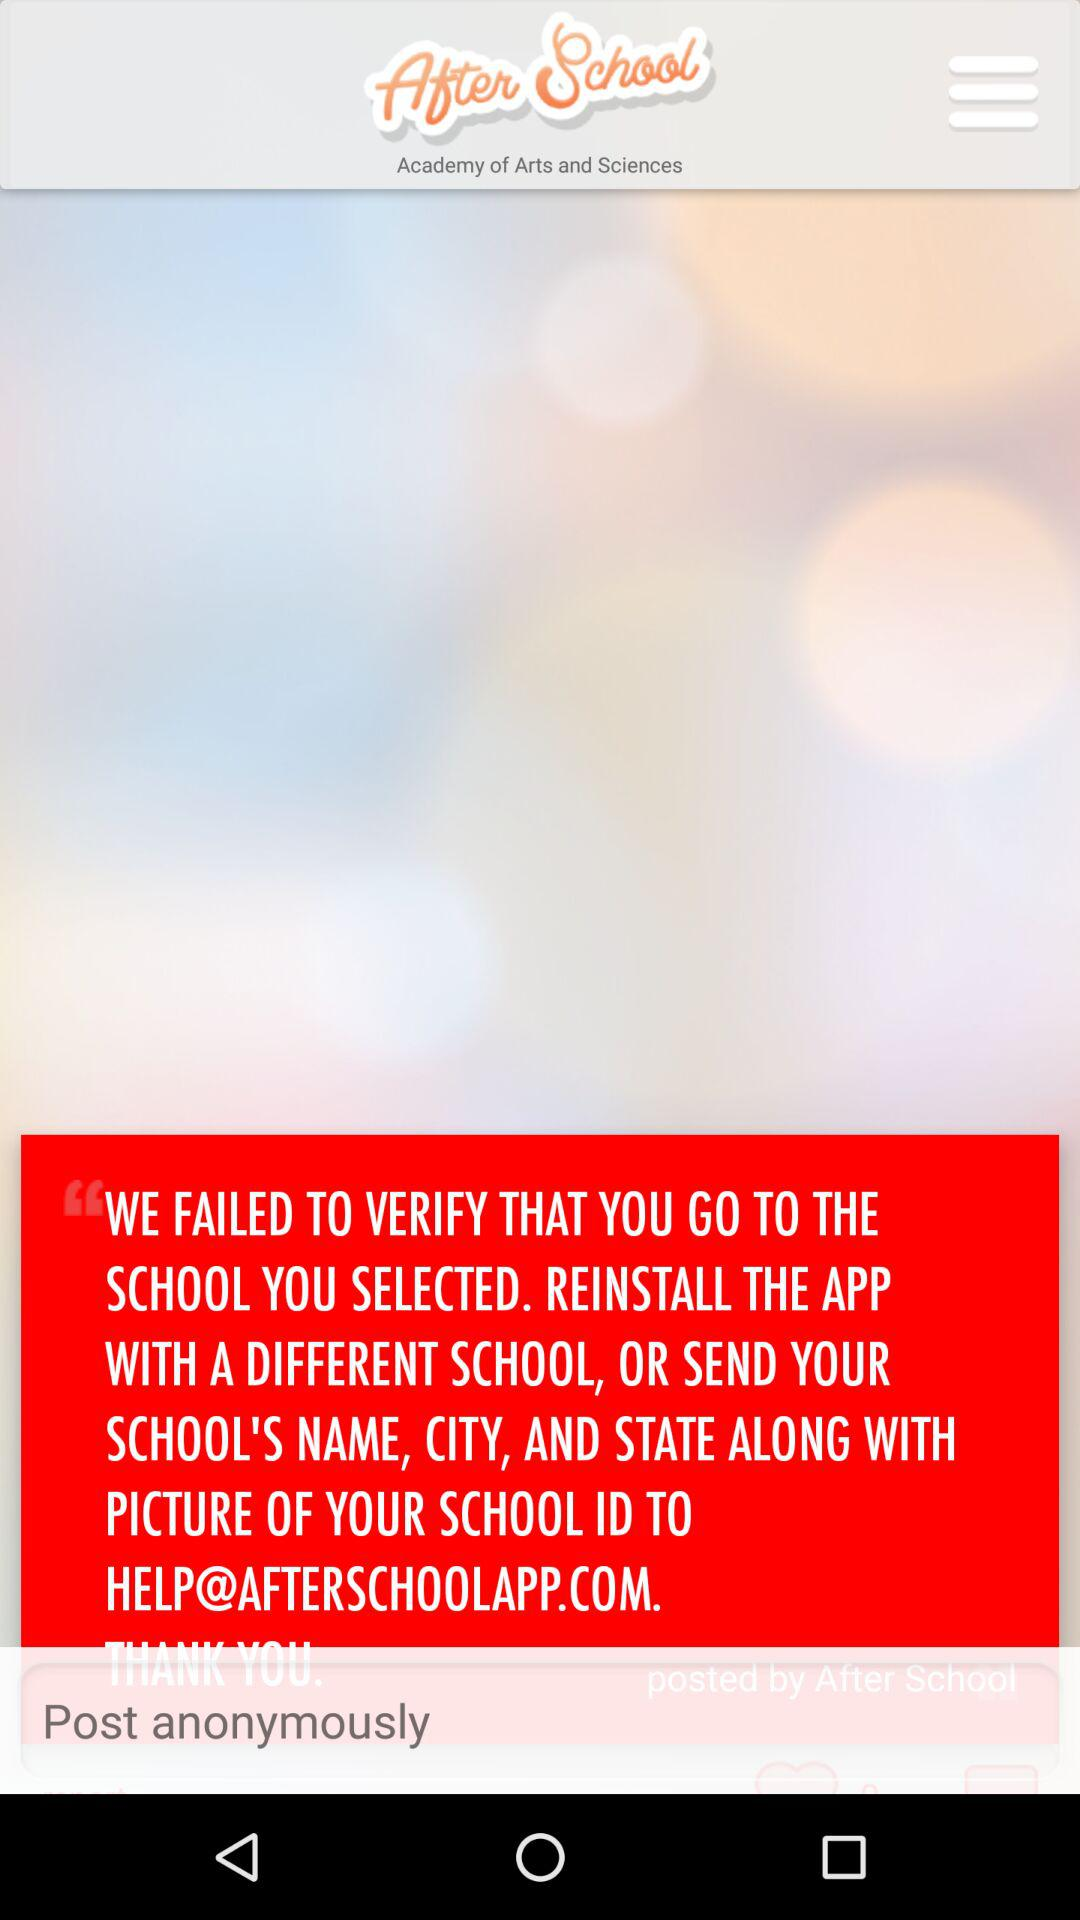What is the name of the application? The application name is "After School". 